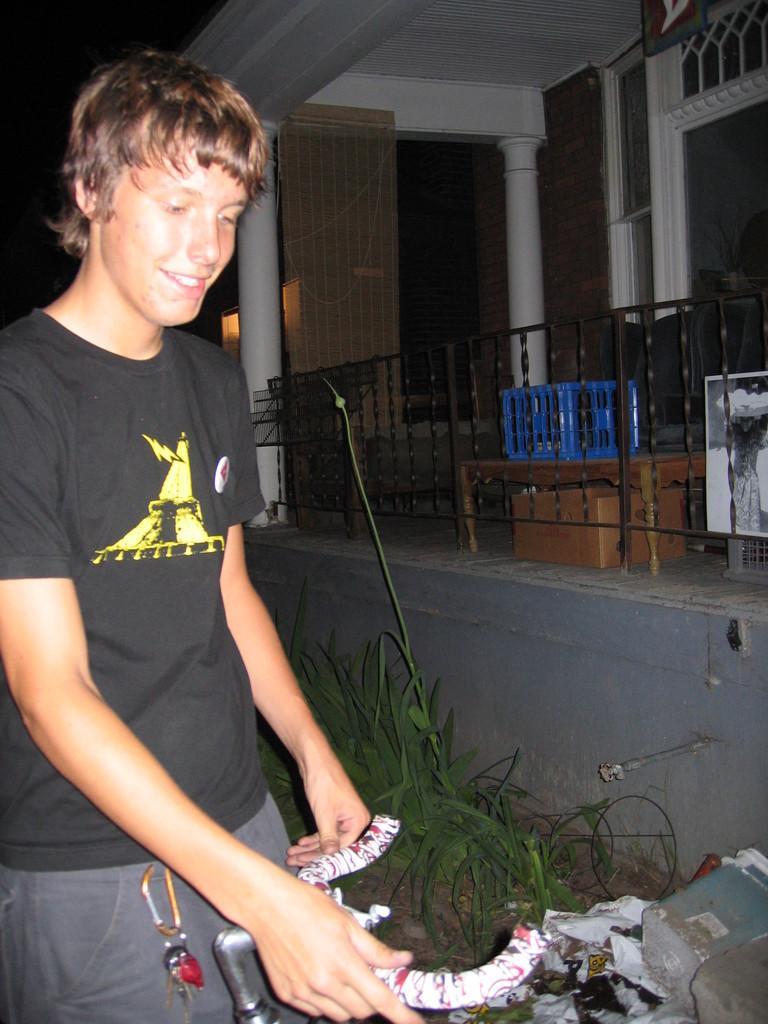Please provide a concise description of this image. In the image on the left side there is a man standing and holding an object in his hands. And there are keys in the pocket of a man. Beside him there are plants. And there is a wall with railings. Behind the railings there are boxes. And also there are pillars, roofs and walls. 